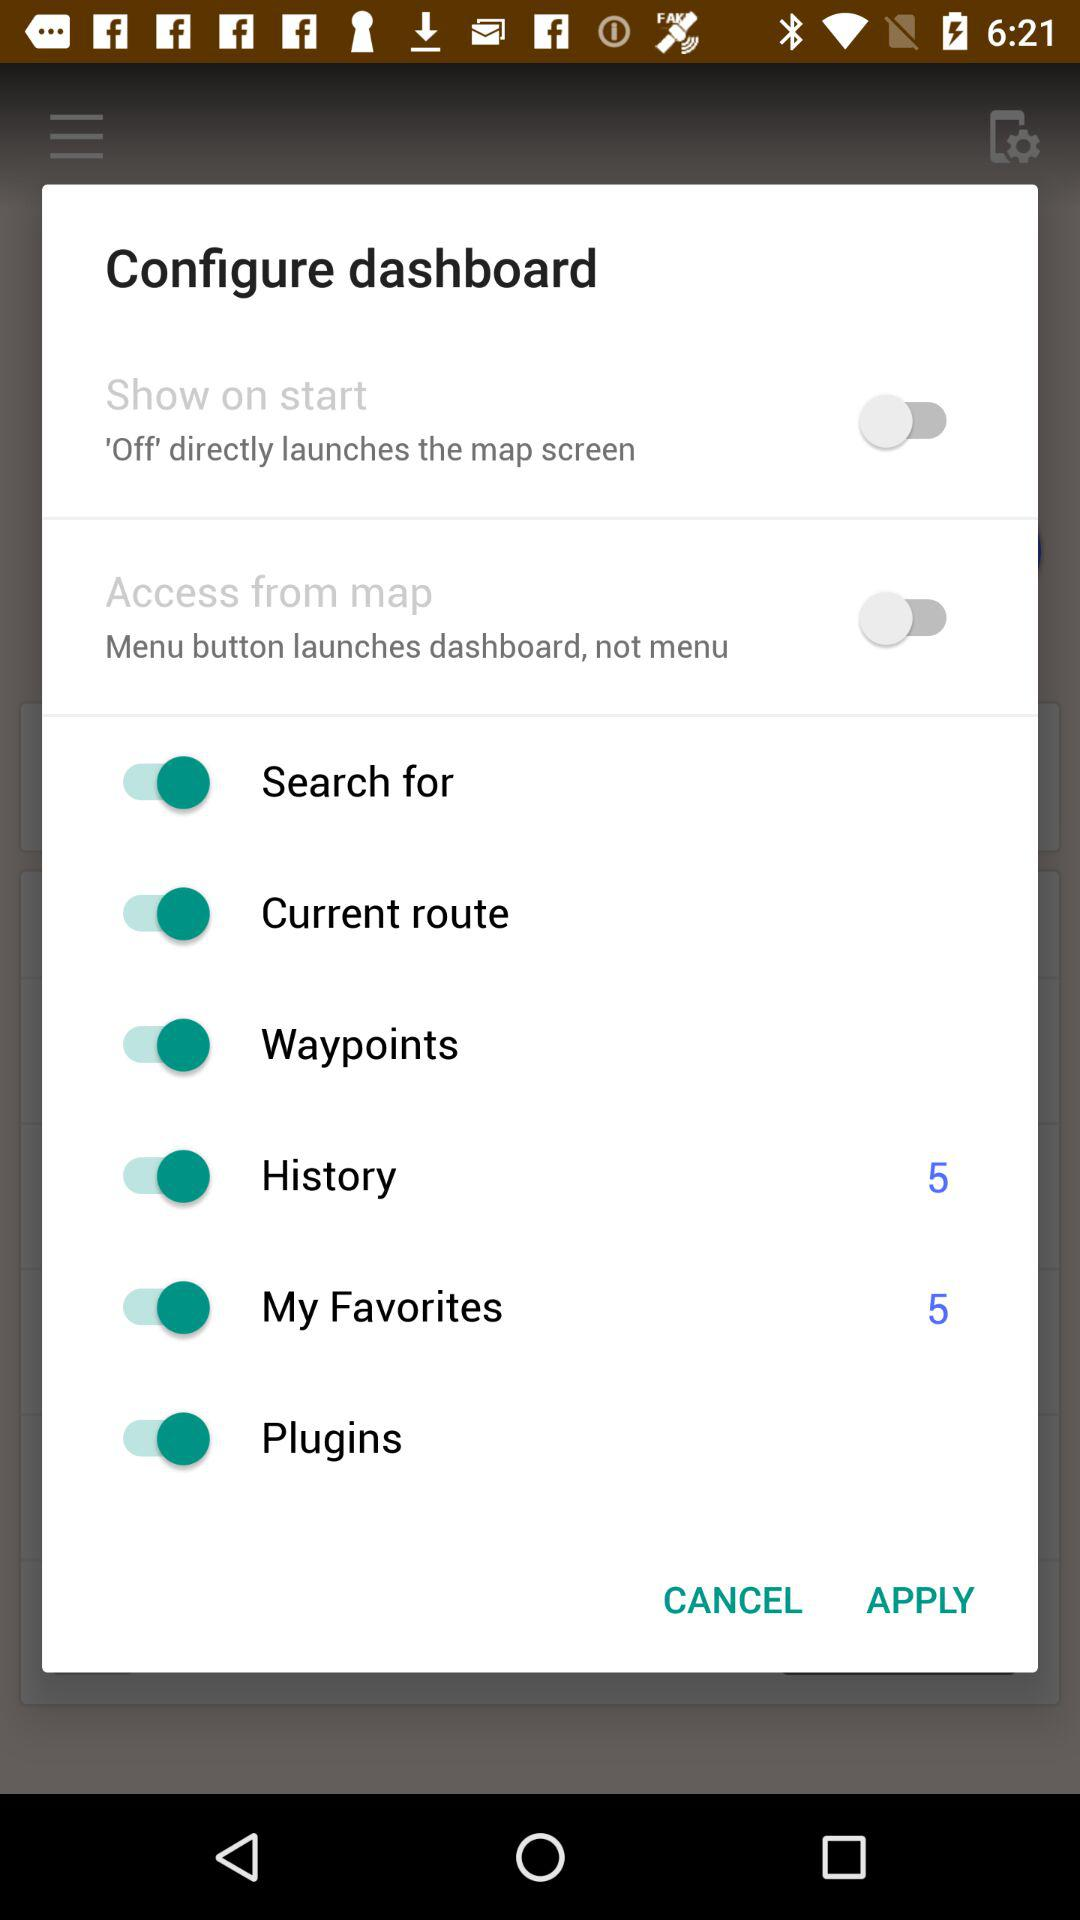How many "My Favorites" notifications are there? There are 5 notifications. 